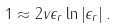<formula> <loc_0><loc_0><loc_500><loc_500>1 \approx 2 v \epsilon _ { r } \ln \left | \epsilon _ { r } \right | .</formula> 